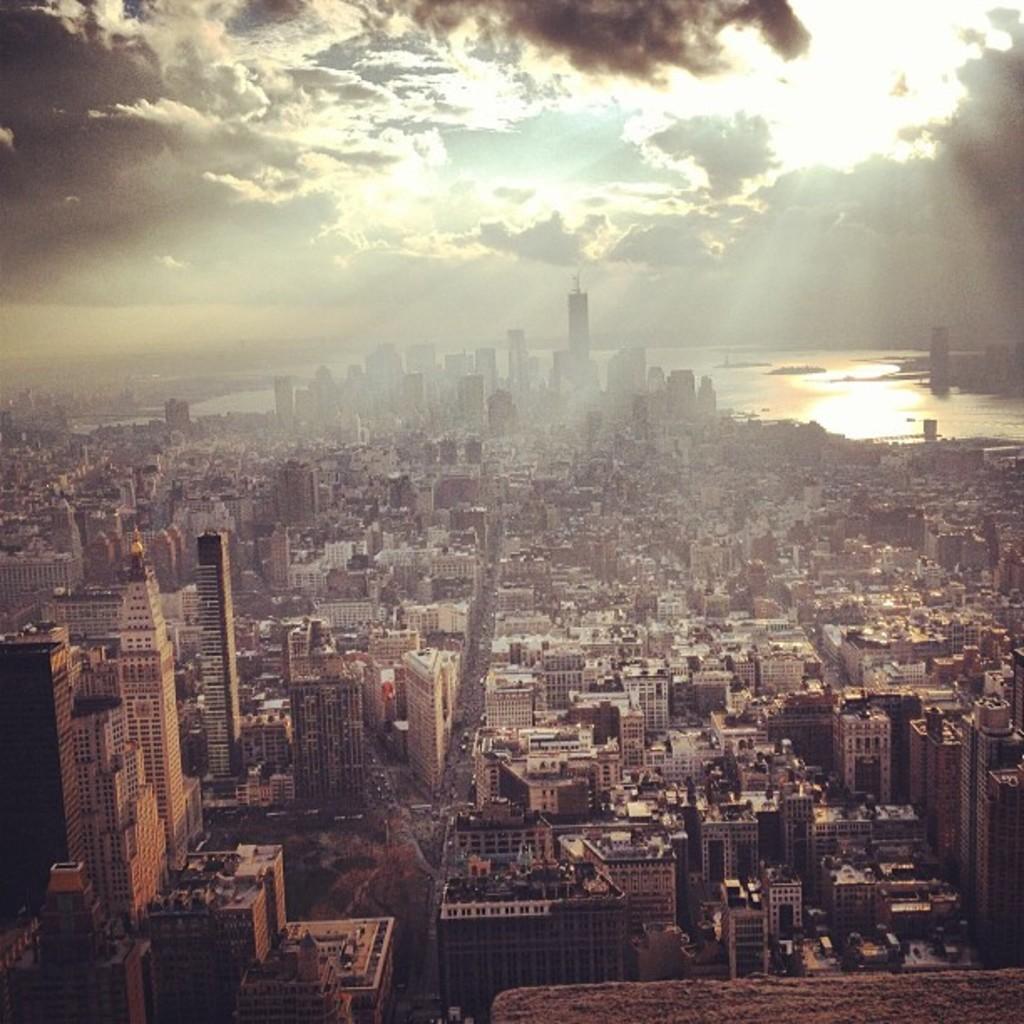Please provide a concise description of this image. In this image I can see number of buildings, the road and few vehicles on the road. In the background I can see water, few buildings, the sky and the sun. 